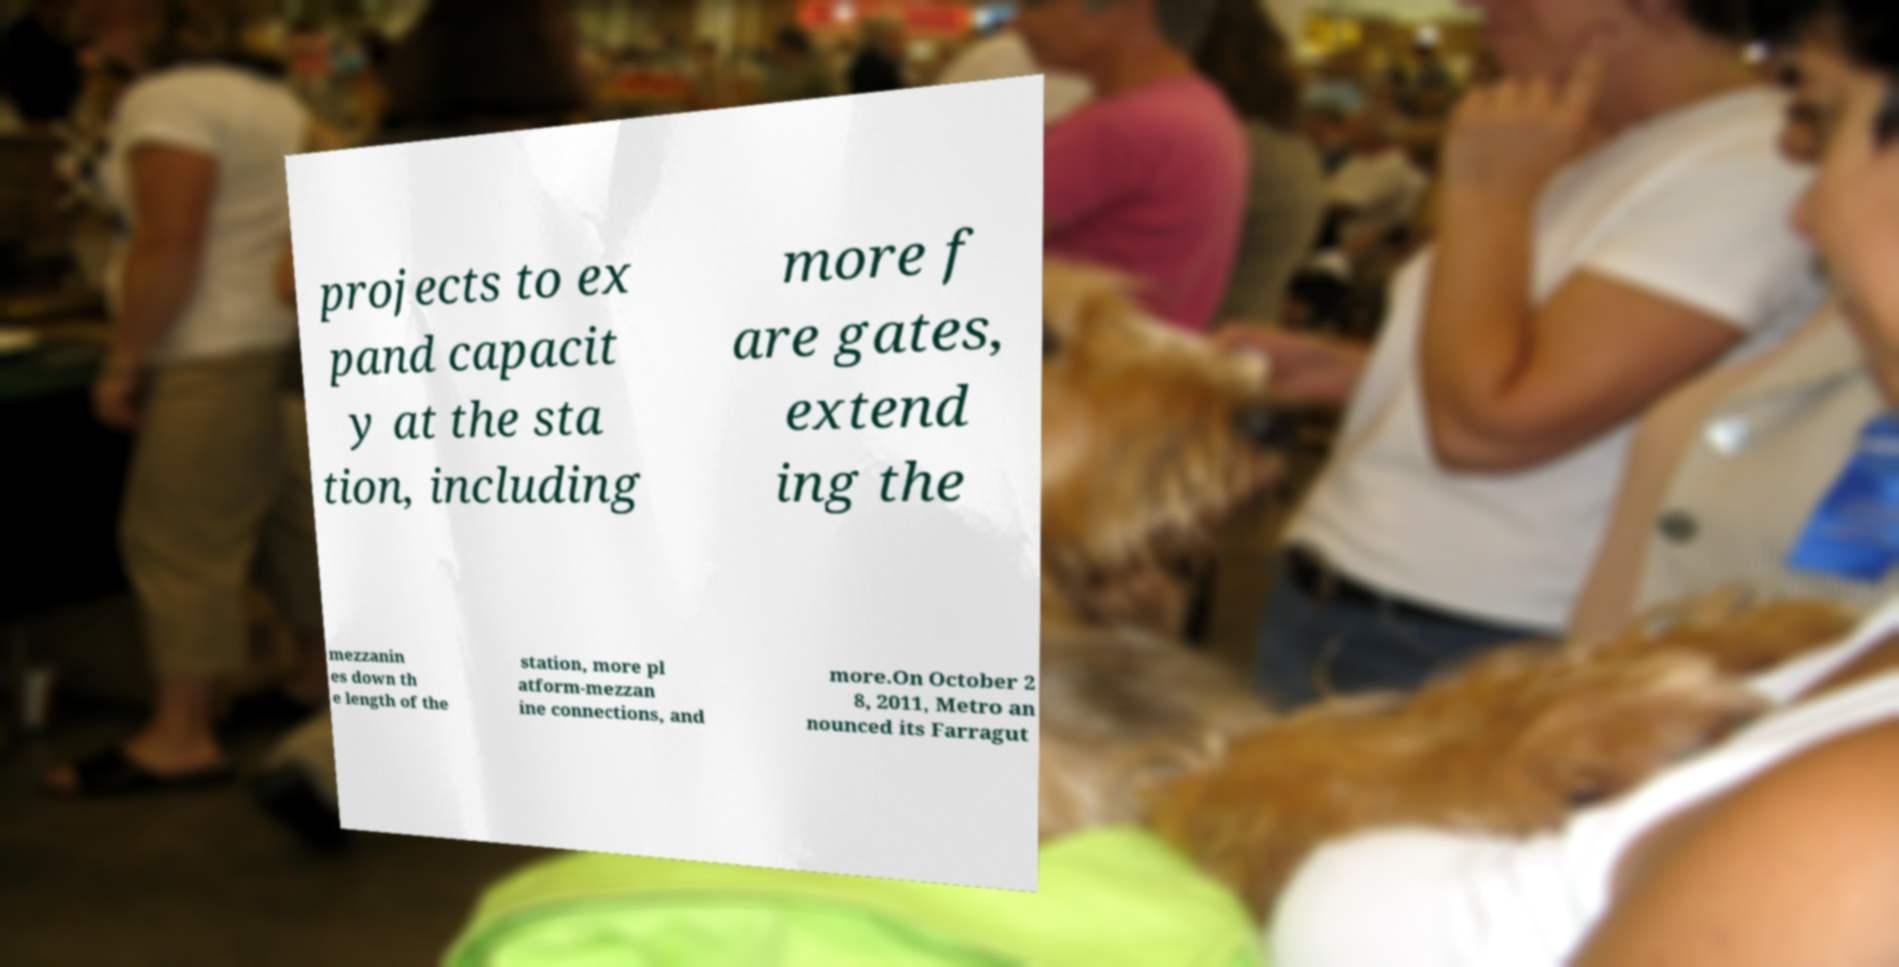There's text embedded in this image that I need extracted. Can you transcribe it verbatim? projects to ex pand capacit y at the sta tion, including more f are gates, extend ing the mezzanin es down th e length of the station, more pl atform-mezzan ine connections, and more.On October 2 8, 2011, Metro an nounced its Farragut 